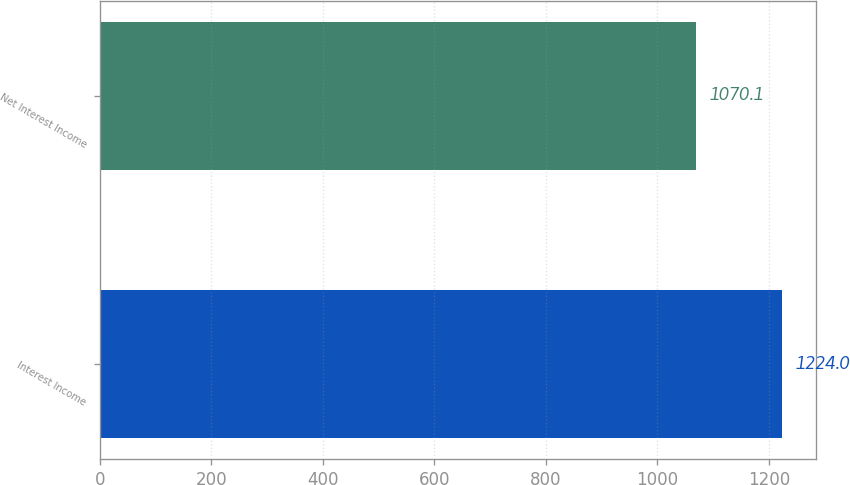Convert chart. <chart><loc_0><loc_0><loc_500><loc_500><bar_chart><fcel>Interest Income<fcel>Net Interest Income<nl><fcel>1224<fcel>1070.1<nl></chart> 